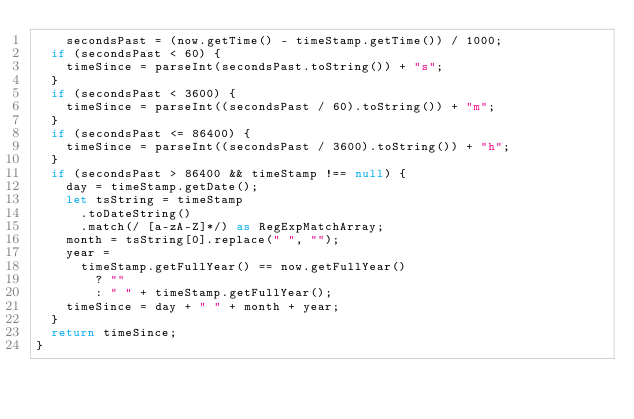<code> <loc_0><loc_0><loc_500><loc_500><_TypeScript_>    secondsPast = (now.getTime() - timeStamp.getTime()) / 1000;
  if (secondsPast < 60) {
    timeSince = parseInt(secondsPast.toString()) + "s";
  }
  if (secondsPast < 3600) {
    timeSince = parseInt((secondsPast / 60).toString()) + "m";
  }
  if (secondsPast <= 86400) {
    timeSince = parseInt((secondsPast / 3600).toString()) + "h";
  }
  if (secondsPast > 86400 && timeStamp !== null) {
    day = timeStamp.getDate();
    let tsString = timeStamp
      .toDateString()
      .match(/ [a-zA-Z]*/) as RegExpMatchArray;
    month = tsString[0].replace(" ", "");
    year =
      timeStamp.getFullYear() == now.getFullYear()
        ? ""
        : " " + timeStamp.getFullYear();
    timeSince = day + " " + month + year;
  }
  return timeSince;
}
</code> 